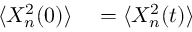<formula> <loc_0><loc_0><loc_500><loc_500>\begin{array} { r l } { \langle X _ { n } ^ { 2 } ( 0 ) \rangle } & = \langle X _ { n } ^ { 2 } ( t ) \rangle } \end{array}</formula> 